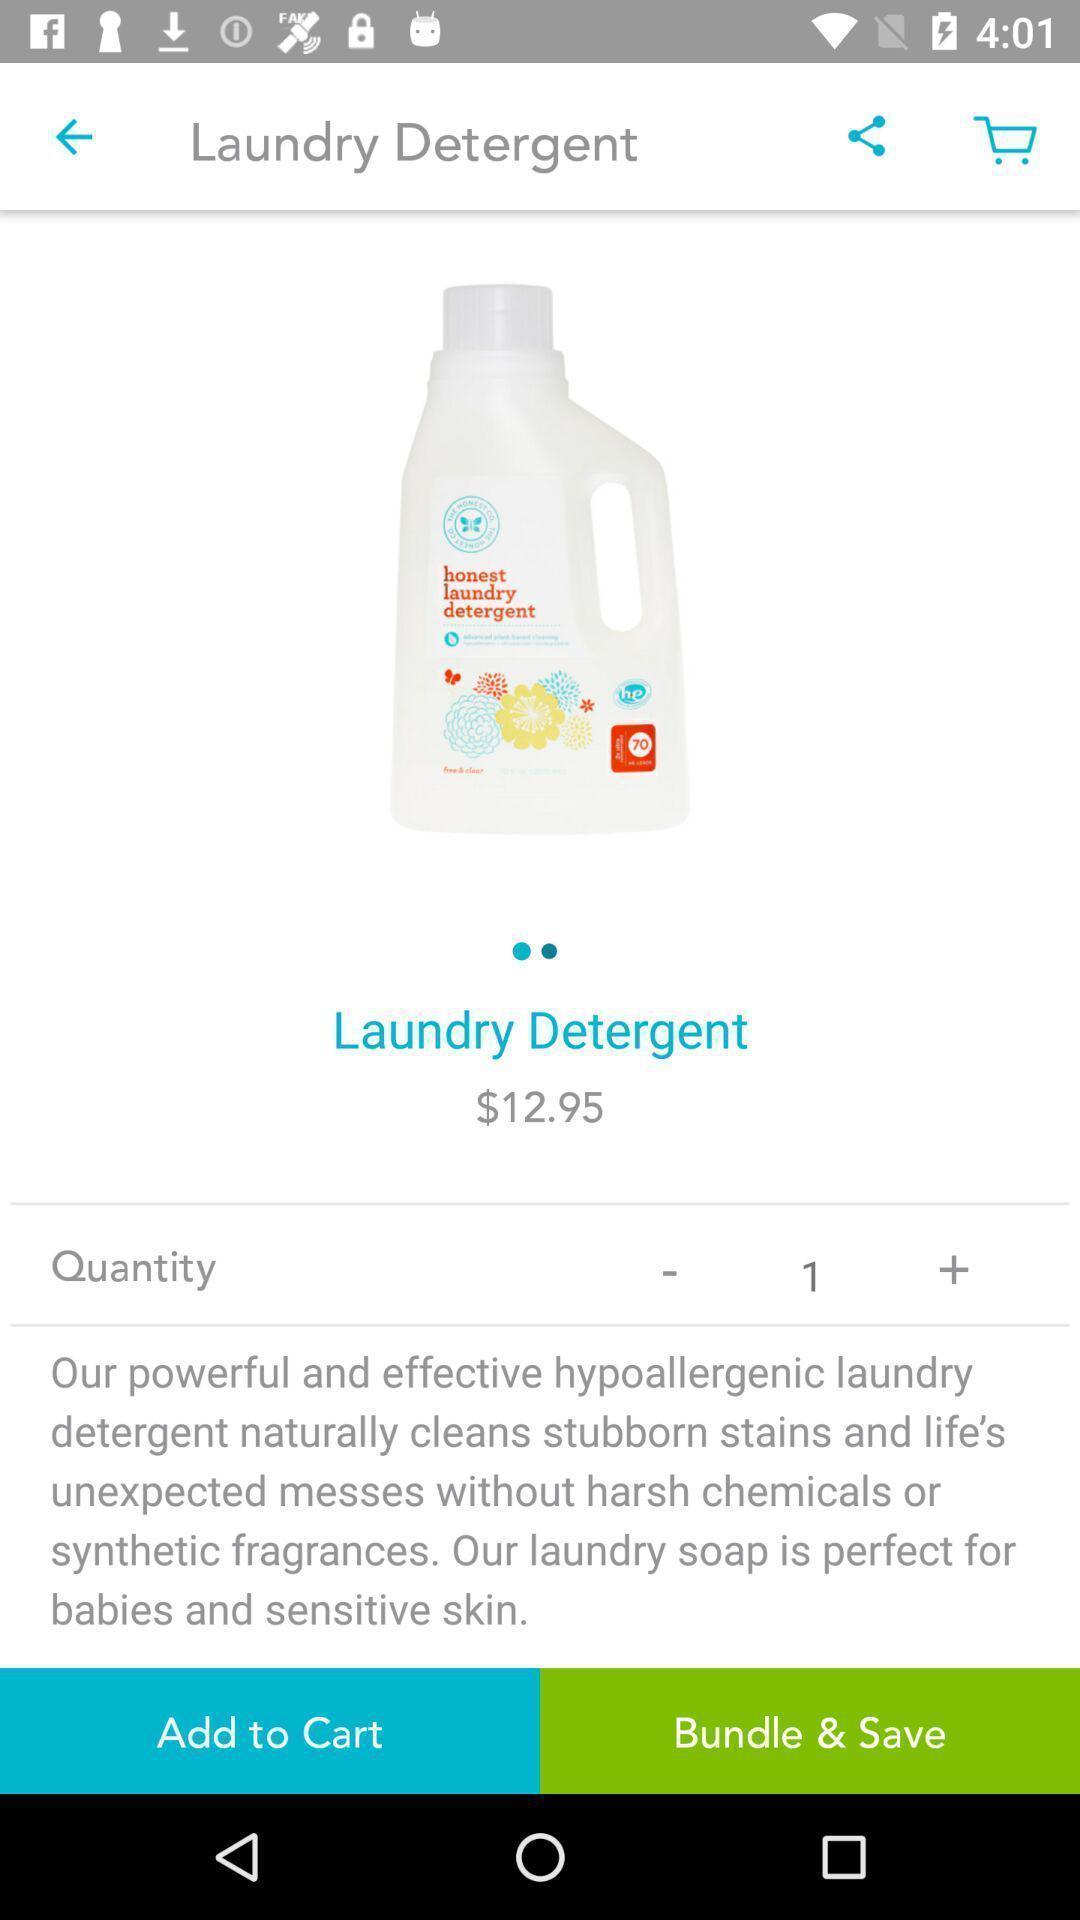Please provide a description for this image. Screen shows multiple options in a shopping application. 